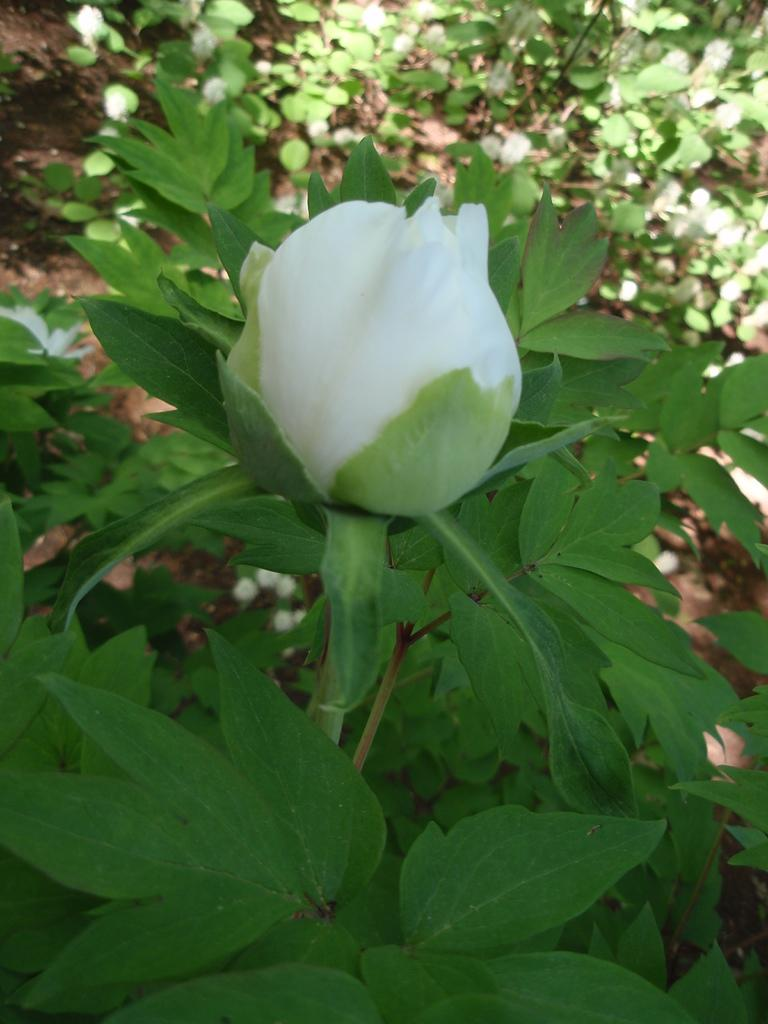What type of living organisms can be seen in the image? Plants and trees are visible in the image. What specific feature can be observed on the plants? The plants have flowers. What color are the flowers on the plants? The flowers are white in color. What type of vegetation is present in the image besides the plants? Trees are present in the image. What is visible under the trees in the image? Mud is visible under the trees. How many pigs are standing in line in the image? There are no pigs present in the image. What type of treatment is being administered to the plants in the image? There is no treatment being administered to the plants in the image; they are simply growing naturally. 